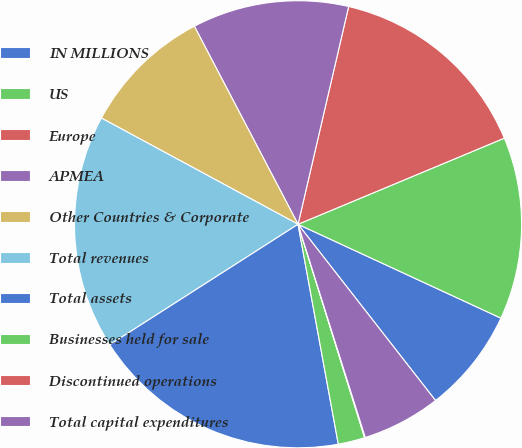Convert chart to OTSL. <chart><loc_0><loc_0><loc_500><loc_500><pie_chart><fcel>IN MILLIONS<fcel>US<fcel>Europe<fcel>APMEA<fcel>Other Countries & Corporate<fcel>Total revenues<fcel>Total assets<fcel>Businesses held for sale<fcel>Discontinued operations<fcel>Total capital expenditures<nl><fcel>7.56%<fcel>13.19%<fcel>15.07%<fcel>11.31%<fcel>9.44%<fcel>16.94%<fcel>18.82%<fcel>1.93%<fcel>0.05%<fcel>5.68%<nl></chart> 